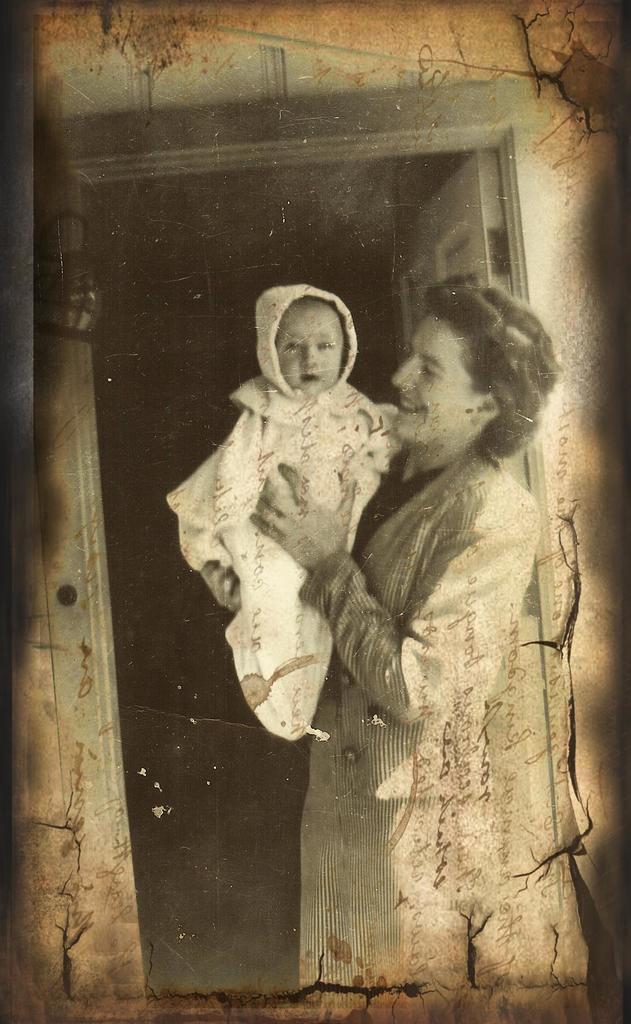Could you give a brief overview of what you see in this image? This is a black and white pic. Here a woman is standing and holding a baby in her hands. In the background there is a wall and door. 